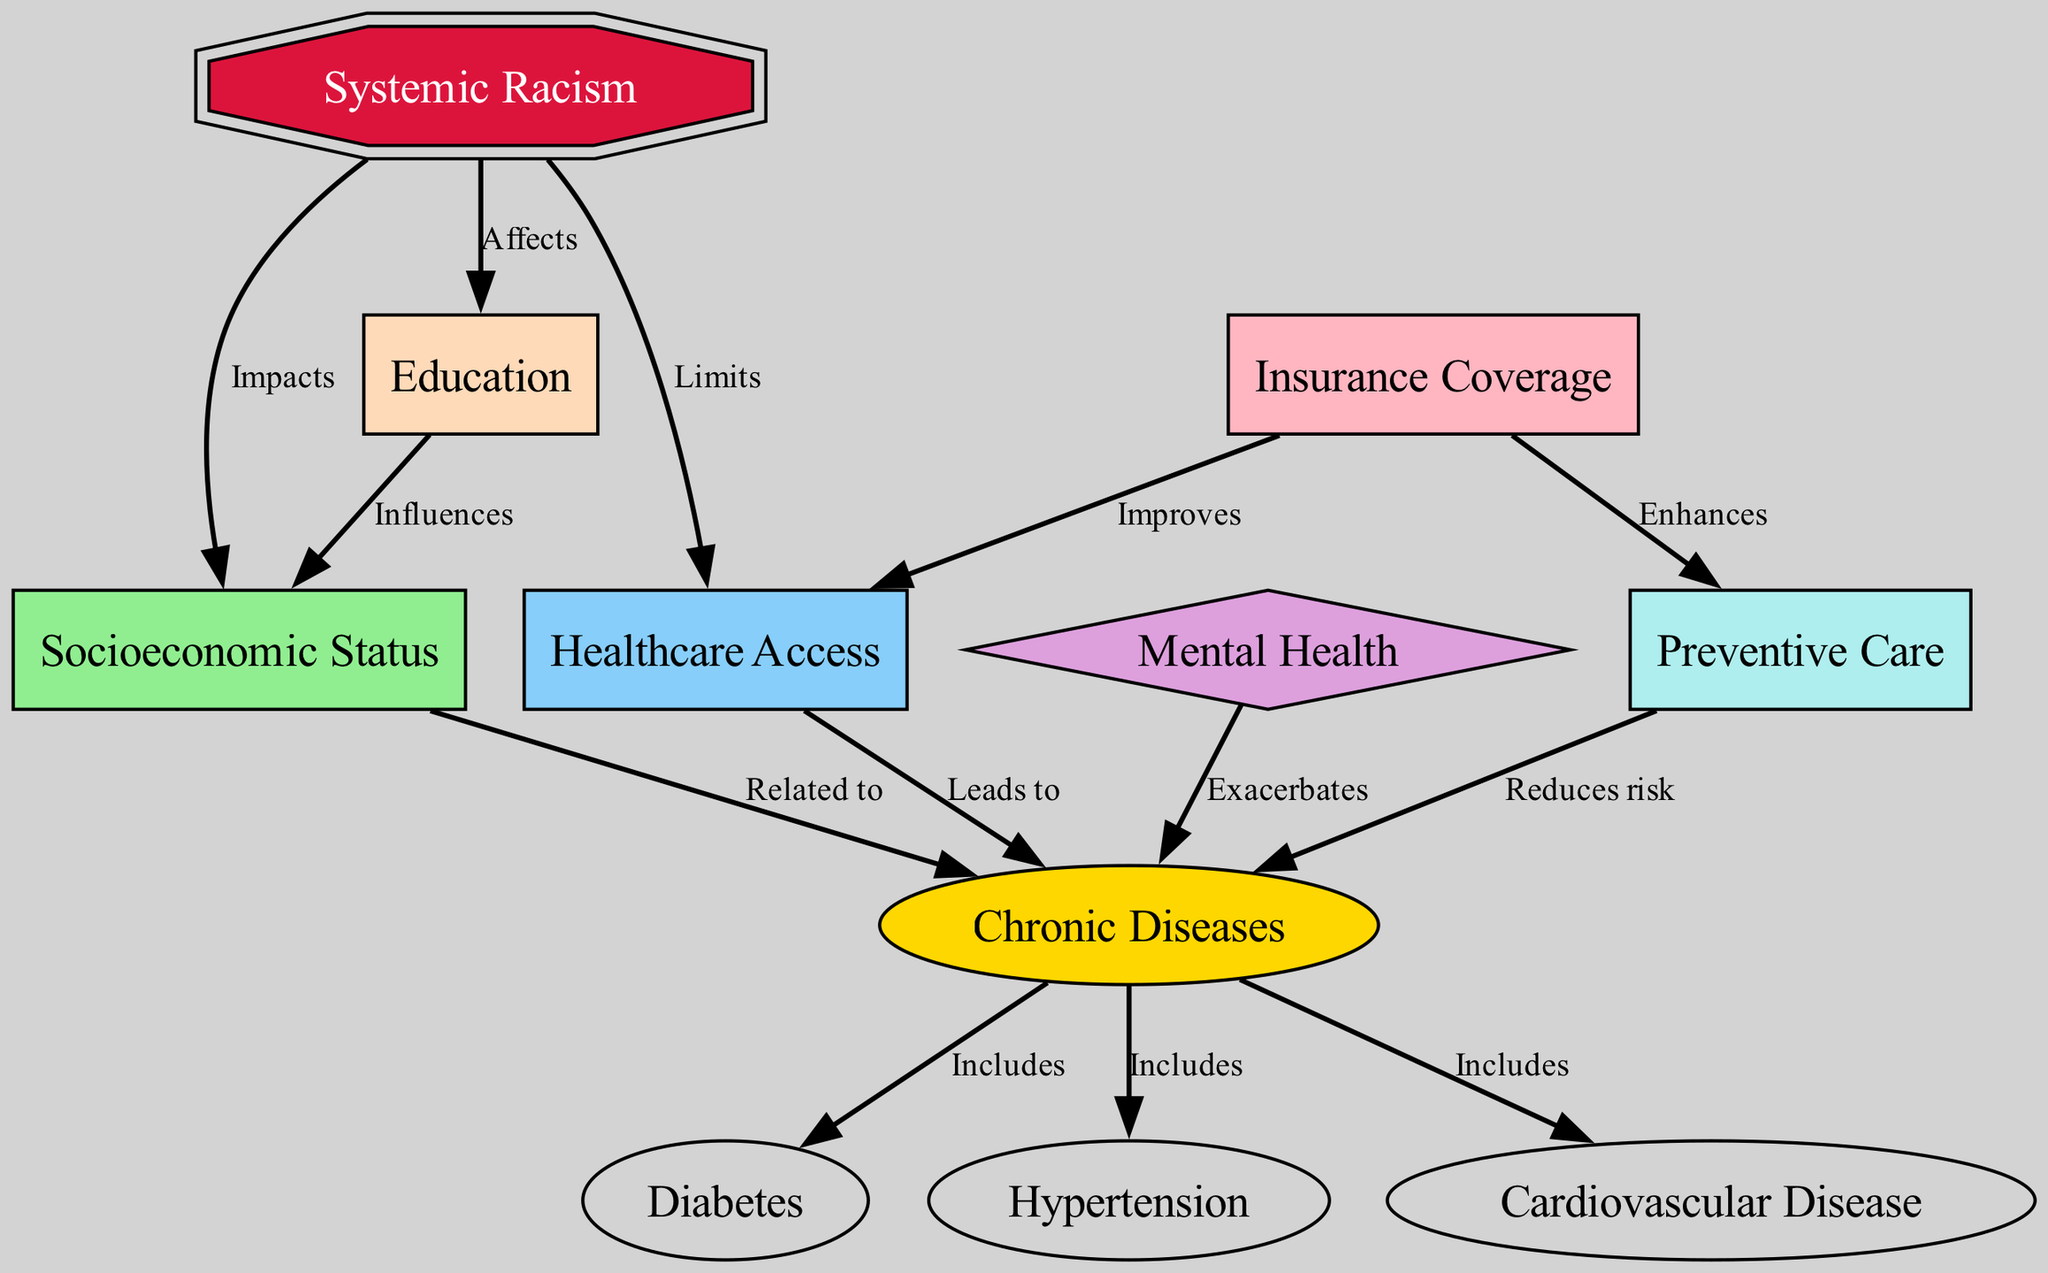What is the primary factor affecting healthcare access? The diagram indicates that systemic racism is the primary factor that impacts healthcare access, as illustrated by the arrow leading from "Systemic Racism" to "Healthcare Access" labeled "Limits."
Answer: systemic racism Which chronic diseases are included in this diagram? The edge from "Chronic Diseases" includes arrows pointing to "Diabetes," "Hypertension," and "Cardiovascular Disease," showing clear relationships of inclusion.
Answer: diabetes, hypertension, cardiovascular disease How many nodes are present in this diagram? By counting the distinct labeled nodes listed in the diagram, we identify a total of eleven nodes.
Answer: 11 What influence does education have according to the diagram? The edge from "Education" to "Socioeconomic Status" labeled "Influences" shows how education affects socioeconomic status, which in turn relates to chronic diseases.
Answer: influences socioeconomic status What is the relationship between healthcare access and chronic diseases? The diagram establishes a direct connection from "Healthcare Access" to "Chronic Diseases," with the edge labeled "Leads to," indicating that reduced access leads to increased chronic diseases.
Answer: leads to How does mental health relate to chronic diseases in the diagram? The arrow from "Mental Health" to "Chronic Diseases" labeled "Exacerbates" depicts that mental health issues can worsen chronic diseases, showing an exacerbating relationship.
Answer: exacerbates Which factor improves healthcare access according to the diagram? The connection from "Insurance Coverage" to "Healthcare Access" is labeled "Improves," denoting that better insurance coverage enhances access to healthcare services.
Answer: insurance coverage What role does preventive care play in chronic diseases? The diagram indicates that "Preventive Care" is associated with "Chronic Diseases" through an arrow labeled "Reduces risk," which suggests that it helps decrease the incidence of chronic diseases.
Answer: reduces risk Which node directly impacts socioeconomic status in the diagram? The edge from "Systemic Racism" to "Socioeconomic Status" labeled "Impacts" clearly indicates that systemic racism directly affects socioeconomic status.
Answer: systemic racism 